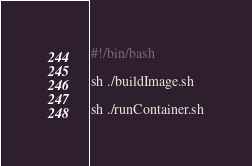<code> <loc_0><loc_0><loc_500><loc_500><_Bash_>#!/bin/bash

sh ./buildImage.sh

sh ./runContainer.sh</code> 